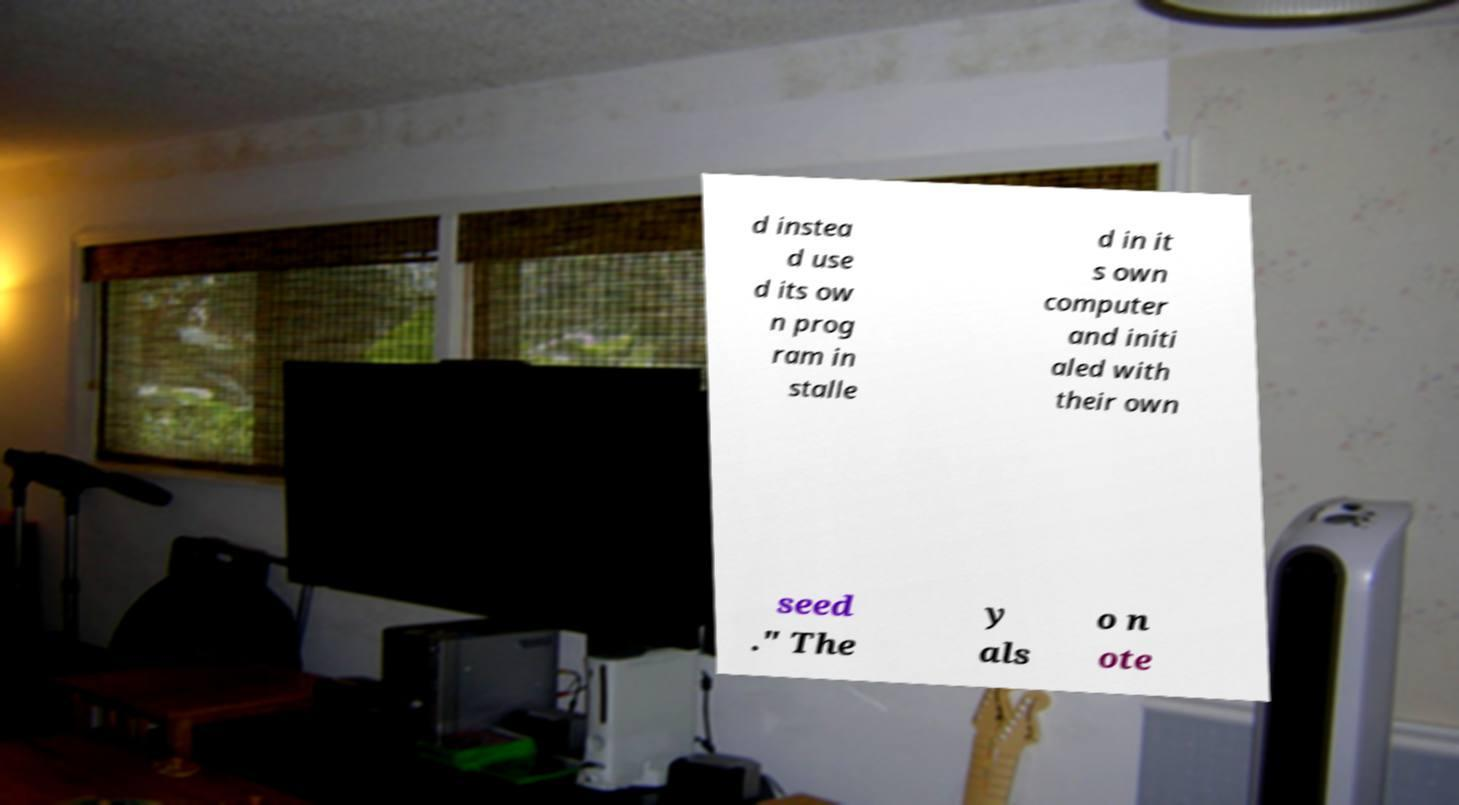Can you read and provide the text displayed in the image?This photo seems to have some interesting text. Can you extract and type it out for me? d instea d use d its ow n prog ram in stalle d in it s own computer and initi aled with their own seed ." The y als o n ote 